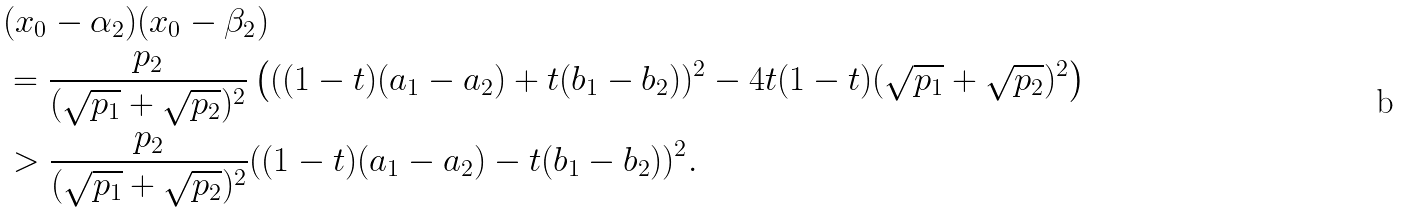<formula> <loc_0><loc_0><loc_500><loc_500>& ( x _ { 0 } - \alpha _ { 2 } ) ( x _ { 0 } - \beta _ { 2 } ) \\ & = \frac { p _ { 2 } } { ( \sqrt { p _ { 1 } } + \sqrt { p _ { 2 } } ) ^ { 2 } } \left ( ( ( 1 - t ) ( a _ { 1 } - a _ { 2 } ) + t ( b _ { 1 } - b _ { 2 } ) ) ^ { 2 } - 4 t ( 1 - t ) ( \sqrt { p _ { 1 } } + \sqrt { p _ { 2 } } ) ^ { 2 } \right ) \\ & > \frac { p _ { 2 } } { ( \sqrt { p _ { 1 } } + \sqrt { p _ { 2 } } ) ^ { 2 } } ( ( 1 - t ) ( a _ { 1 } - a _ { 2 } ) - t ( b _ { 1 } - b _ { 2 } ) ) ^ { 2 } .</formula> 